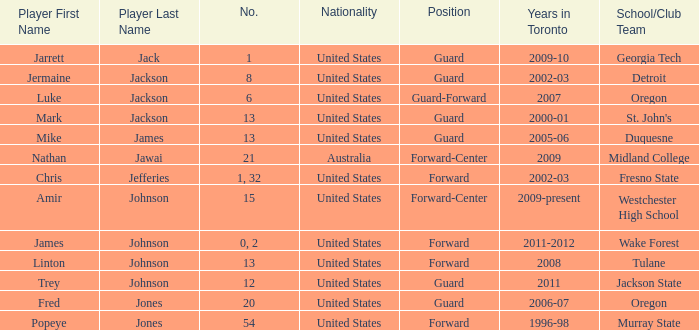What are the total amount of numbers on the Toronto team in 2005-06? 1.0. 